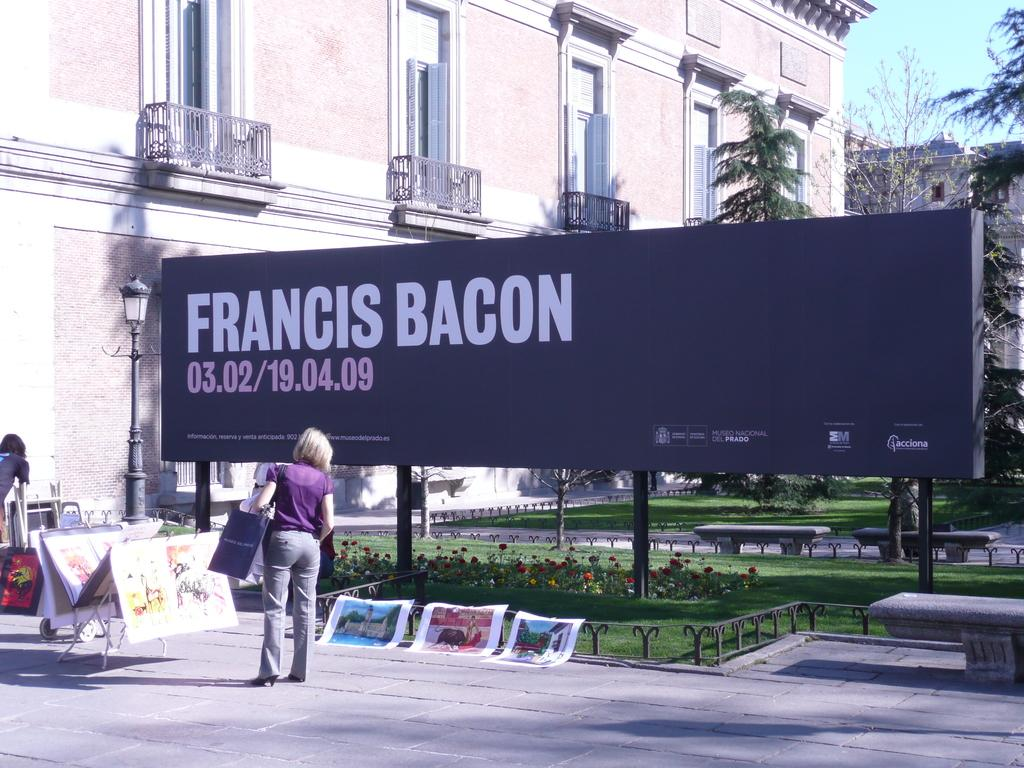Provide a one-sentence caption for the provided image. A billboard promoting Francis Bacon has some artwork displayed around it, with a woman looking at some paintings. 